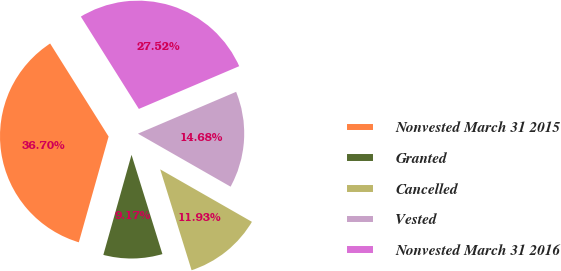Convert chart to OTSL. <chart><loc_0><loc_0><loc_500><loc_500><pie_chart><fcel>Nonvested March 31 2015<fcel>Granted<fcel>Cancelled<fcel>Vested<fcel>Nonvested March 31 2016<nl><fcel>36.7%<fcel>9.17%<fcel>11.93%<fcel>14.68%<fcel>27.52%<nl></chart> 